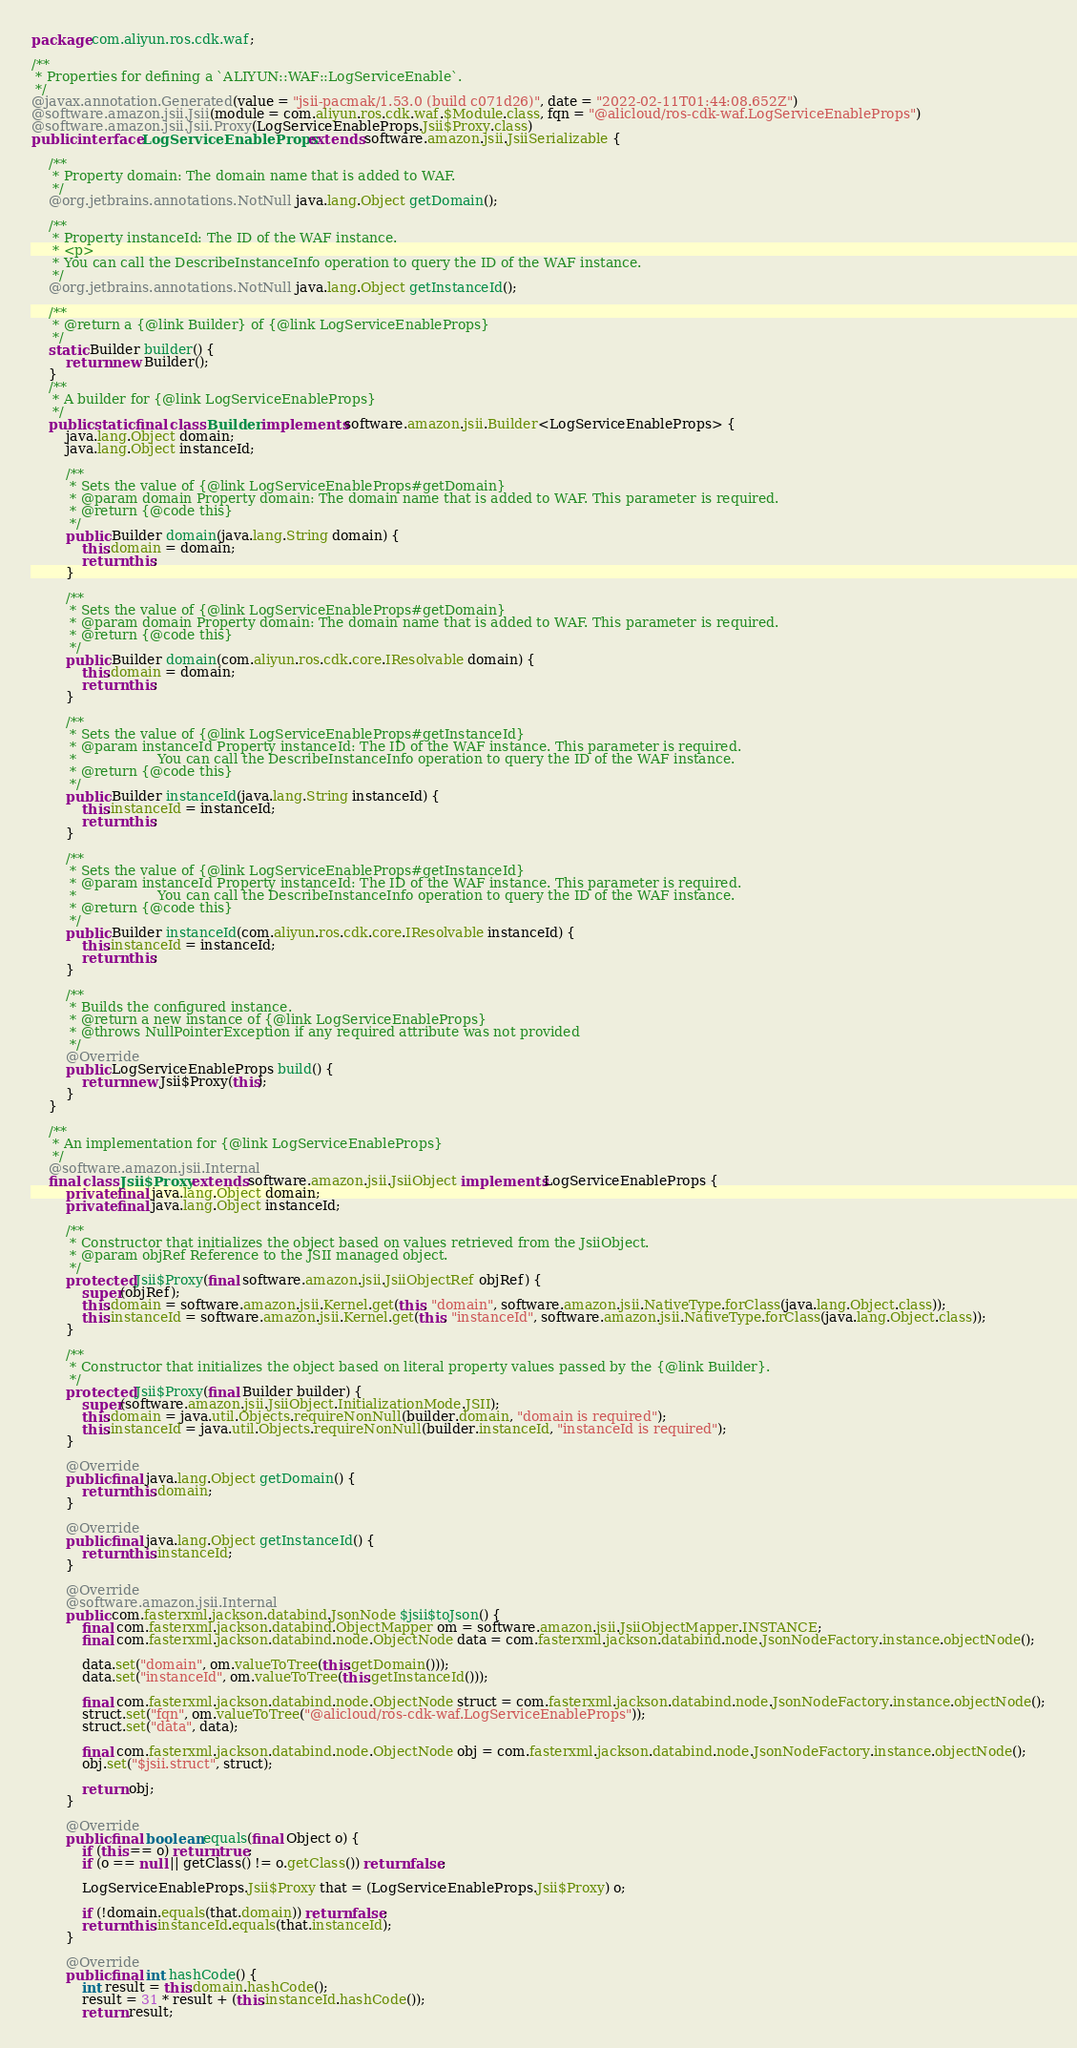<code> <loc_0><loc_0><loc_500><loc_500><_Java_>package com.aliyun.ros.cdk.waf;

/**
 * Properties for defining a `ALIYUN::WAF::LogServiceEnable`.
 */
@javax.annotation.Generated(value = "jsii-pacmak/1.53.0 (build c071d26)", date = "2022-02-11T01:44:08.652Z")
@software.amazon.jsii.Jsii(module = com.aliyun.ros.cdk.waf.$Module.class, fqn = "@alicloud/ros-cdk-waf.LogServiceEnableProps")
@software.amazon.jsii.Jsii.Proxy(LogServiceEnableProps.Jsii$Proxy.class)
public interface LogServiceEnableProps extends software.amazon.jsii.JsiiSerializable {

    /**
     * Property domain: The domain name that is added to WAF.
     */
    @org.jetbrains.annotations.NotNull java.lang.Object getDomain();

    /**
     * Property instanceId: The ID of the WAF instance.
     * <p>
     * You can call the DescribeInstanceInfo operation to query the ID of the WAF instance.
     */
    @org.jetbrains.annotations.NotNull java.lang.Object getInstanceId();

    /**
     * @return a {@link Builder} of {@link LogServiceEnableProps}
     */
    static Builder builder() {
        return new Builder();
    }
    /**
     * A builder for {@link LogServiceEnableProps}
     */
    public static final class Builder implements software.amazon.jsii.Builder<LogServiceEnableProps> {
        java.lang.Object domain;
        java.lang.Object instanceId;

        /**
         * Sets the value of {@link LogServiceEnableProps#getDomain}
         * @param domain Property domain: The domain name that is added to WAF. This parameter is required.
         * @return {@code this}
         */
        public Builder domain(java.lang.String domain) {
            this.domain = domain;
            return this;
        }

        /**
         * Sets the value of {@link LogServiceEnableProps#getDomain}
         * @param domain Property domain: The domain name that is added to WAF. This parameter is required.
         * @return {@code this}
         */
        public Builder domain(com.aliyun.ros.cdk.core.IResolvable domain) {
            this.domain = domain;
            return this;
        }

        /**
         * Sets the value of {@link LogServiceEnableProps#getInstanceId}
         * @param instanceId Property instanceId: The ID of the WAF instance. This parameter is required.
         *                   You can call the DescribeInstanceInfo operation to query the ID of the WAF instance.
         * @return {@code this}
         */
        public Builder instanceId(java.lang.String instanceId) {
            this.instanceId = instanceId;
            return this;
        }

        /**
         * Sets the value of {@link LogServiceEnableProps#getInstanceId}
         * @param instanceId Property instanceId: The ID of the WAF instance. This parameter is required.
         *                   You can call the DescribeInstanceInfo operation to query the ID of the WAF instance.
         * @return {@code this}
         */
        public Builder instanceId(com.aliyun.ros.cdk.core.IResolvable instanceId) {
            this.instanceId = instanceId;
            return this;
        }

        /**
         * Builds the configured instance.
         * @return a new instance of {@link LogServiceEnableProps}
         * @throws NullPointerException if any required attribute was not provided
         */
        @Override
        public LogServiceEnableProps build() {
            return new Jsii$Proxy(this);
        }
    }

    /**
     * An implementation for {@link LogServiceEnableProps}
     */
    @software.amazon.jsii.Internal
    final class Jsii$Proxy extends software.amazon.jsii.JsiiObject implements LogServiceEnableProps {
        private final java.lang.Object domain;
        private final java.lang.Object instanceId;

        /**
         * Constructor that initializes the object based on values retrieved from the JsiiObject.
         * @param objRef Reference to the JSII managed object.
         */
        protected Jsii$Proxy(final software.amazon.jsii.JsiiObjectRef objRef) {
            super(objRef);
            this.domain = software.amazon.jsii.Kernel.get(this, "domain", software.amazon.jsii.NativeType.forClass(java.lang.Object.class));
            this.instanceId = software.amazon.jsii.Kernel.get(this, "instanceId", software.amazon.jsii.NativeType.forClass(java.lang.Object.class));
        }

        /**
         * Constructor that initializes the object based on literal property values passed by the {@link Builder}.
         */
        protected Jsii$Proxy(final Builder builder) {
            super(software.amazon.jsii.JsiiObject.InitializationMode.JSII);
            this.domain = java.util.Objects.requireNonNull(builder.domain, "domain is required");
            this.instanceId = java.util.Objects.requireNonNull(builder.instanceId, "instanceId is required");
        }

        @Override
        public final java.lang.Object getDomain() {
            return this.domain;
        }

        @Override
        public final java.lang.Object getInstanceId() {
            return this.instanceId;
        }

        @Override
        @software.amazon.jsii.Internal
        public com.fasterxml.jackson.databind.JsonNode $jsii$toJson() {
            final com.fasterxml.jackson.databind.ObjectMapper om = software.amazon.jsii.JsiiObjectMapper.INSTANCE;
            final com.fasterxml.jackson.databind.node.ObjectNode data = com.fasterxml.jackson.databind.node.JsonNodeFactory.instance.objectNode();

            data.set("domain", om.valueToTree(this.getDomain()));
            data.set("instanceId", om.valueToTree(this.getInstanceId()));

            final com.fasterxml.jackson.databind.node.ObjectNode struct = com.fasterxml.jackson.databind.node.JsonNodeFactory.instance.objectNode();
            struct.set("fqn", om.valueToTree("@alicloud/ros-cdk-waf.LogServiceEnableProps"));
            struct.set("data", data);

            final com.fasterxml.jackson.databind.node.ObjectNode obj = com.fasterxml.jackson.databind.node.JsonNodeFactory.instance.objectNode();
            obj.set("$jsii.struct", struct);

            return obj;
        }

        @Override
        public final boolean equals(final Object o) {
            if (this == o) return true;
            if (o == null || getClass() != o.getClass()) return false;

            LogServiceEnableProps.Jsii$Proxy that = (LogServiceEnableProps.Jsii$Proxy) o;

            if (!domain.equals(that.domain)) return false;
            return this.instanceId.equals(that.instanceId);
        }

        @Override
        public final int hashCode() {
            int result = this.domain.hashCode();
            result = 31 * result + (this.instanceId.hashCode());
            return result;</code> 